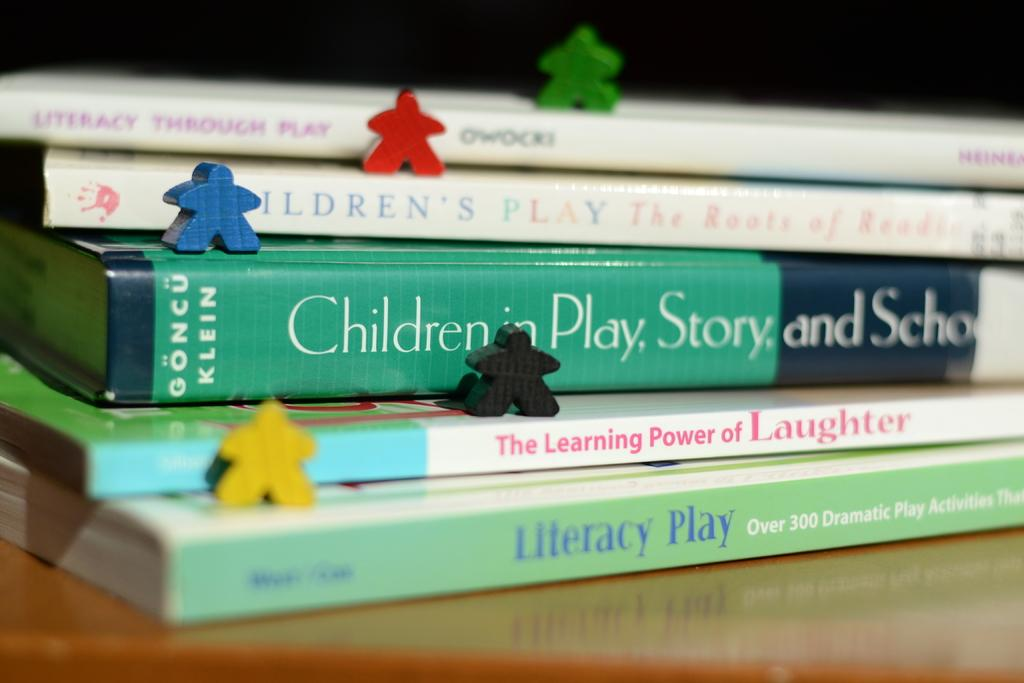<image>
Give a short and clear explanation of the subsequent image. The stack of books includes "The Learning Power of Laughter" and Literacy Play". 